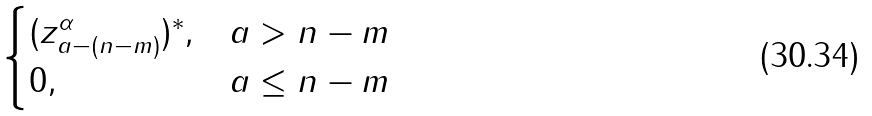Convert formula to latex. <formula><loc_0><loc_0><loc_500><loc_500>\begin{cases} ( z _ { a - ( n - m ) } ^ { \alpha } ) ^ { * } , & a > n - m \\ 0 , & a \leq n - m \end{cases}</formula> 